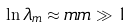Convert formula to latex. <formula><loc_0><loc_0><loc_500><loc_500>\ln \lambda _ { m } \approx m m \gg 1</formula> 